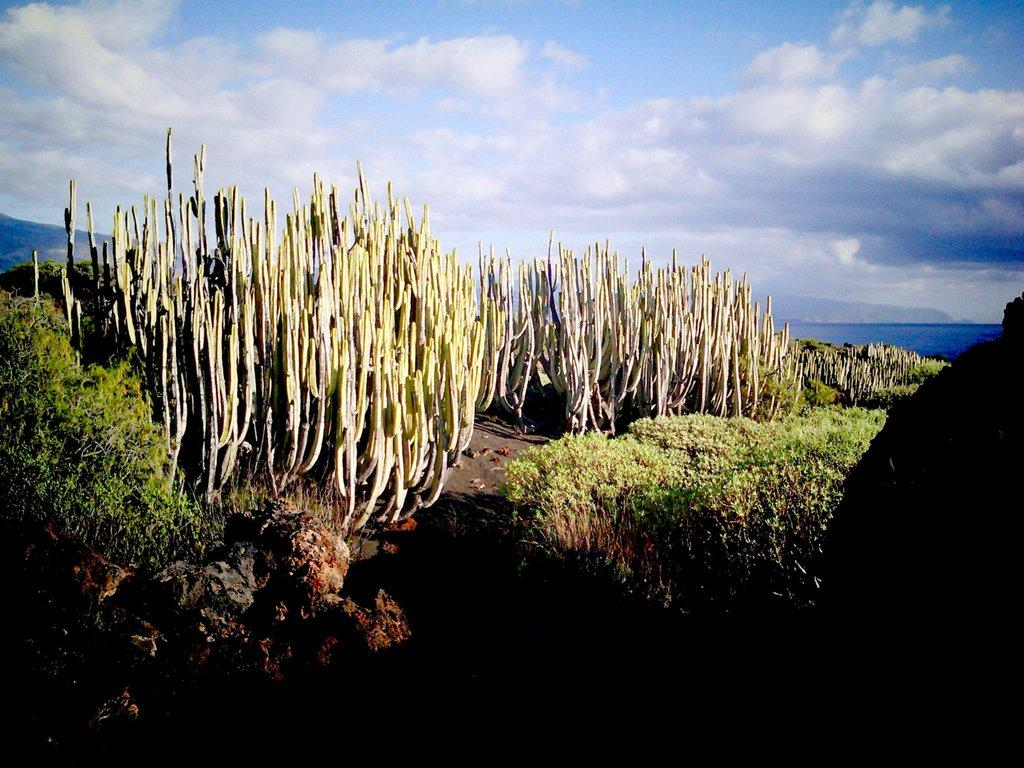What type of plants can be seen in the image? There are cactus plants and other plants in the image. What type of vegetation is present besides the cactus plants? There is grass in the image. What can be found on the floor in the image? There are stones on the floor in the image. What type of horn can be seen on the cactus plants in the image? There are no horns present on the cactus plants in the image. 